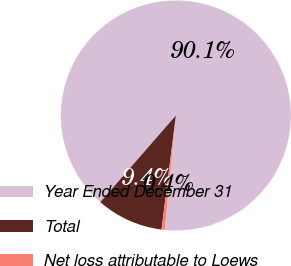Convert chart to OTSL. <chart><loc_0><loc_0><loc_500><loc_500><pie_chart><fcel>Year Ended December 31<fcel>Total<fcel>Net loss attributable to Loews<nl><fcel>90.14%<fcel>9.42%<fcel>0.45%<nl></chart> 